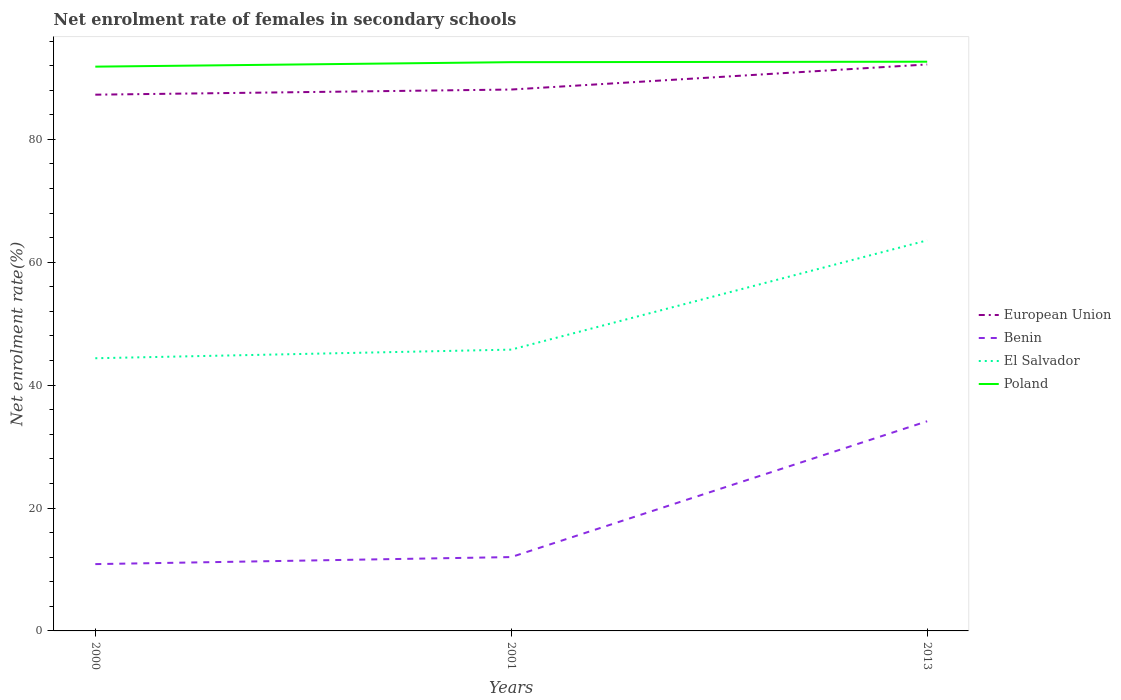Across all years, what is the maximum net enrolment rate of females in secondary schools in Benin?
Your response must be concise. 10.87. What is the total net enrolment rate of females in secondary schools in Poland in the graph?
Offer a terse response. -0.08. What is the difference between the highest and the second highest net enrolment rate of females in secondary schools in Benin?
Make the answer very short. 23.25. What is the difference between the highest and the lowest net enrolment rate of females in secondary schools in Poland?
Your response must be concise. 2. Does the graph contain any zero values?
Give a very brief answer. No. How are the legend labels stacked?
Keep it short and to the point. Vertical. What is the title of the graph?
Provide a succinct answer. Net enrolment rate of females in secondary schools. What is the label or title of the Y-axis?
Your answer should be very brief. Net enrolment rate(%). What is the Net enrolment rate(%) in European Union in 2000?
Provide a short and direct response. 87.27. What is the Net enrolment rate(%) in Benin in 2000?
Keep it short and to the point. 10.87. What is the Net enrolment rate(%) in El Salvador in 2000?
Provide a succinct answer. 44.38. What is the Net enrolment rate(%) of Poland in 2000?
Offer a terse response. 91.83. What is the Net enrolment rate(%) of European Union in 2001?
Offer a terse response. 88.1. What is the Net enrolment rate(%) of Benin in 2001?
Ensure brevity in your answer.  12.02. What is the Net enrolment rate(%) in El Salvador in 2001?
Your answer should be very brief. 45.78. What is the Net enrolment rate(%) in Poland in 2001?
Offer a terse response. 92.56. What is the Net enrolment rate(%) in European Union in 2013?
Give a very brief answer. 92.19. What is the Net enrolment rate(%) in Benin in 2013?
Keep it short and to the point. 34.12. What is the Net enrolment rate(%) of El Salvador in 2013?
Keep it short and to the point. 63.56. What is the Net enrolment rate(%) in Poland in 2013?
Your response must be concise. 92.63. Across all years, what is the maximum Net enrolment rate(%) of European Union?
Your response must be concise. 92.19. Across all years, what is the maximum Net enrolment rate(%) of Benin?
Your answer should be very brief. 34.12. Across all years, what is the maximum Net enrolment rate(%) of El Salvador?
Offer a terse response. 63.56. Across all years, what is the maximum Net enrolment rate(%) in Poland?
Your answer should be compact. 92.63. Across all years, what is the minimum Net enrolment rate(%) in European Union?
Provide a short and direct response. 87.27. Across all years, what is the minimum Net enrolment rate(%) in Benin?
Offer a terse response. 10.87. Across all years, what is the minimum Net enrolment rate(%) in El Salvador?
Give a very brief answer. 44.38. Across all years, what is the minimum Net enrolment rate(%) of Poland?
Keep it short and to the point. 91.83. What is the total Net enrolment rate(%) in European Union in the graph?
Make the answer very short. 267.56. What is the total Net enrolment rate(%) in Benin in the graph?
Your answer should be compact. 57.01. What is the total Net enrolment rate(%) of El Salvador in the graph?
Make the answer very short. 153.72. What is the total Net enrolment rate(%) of Poland in the graph?
Provide a short and direct response. 277.02. What is the difference between the Net enrolment rate(%) of European Union in 2000 and that in 2001?
Your answer should be compact. -0.84. What is the difference between the Net enrolment rate(%) of Benin in 2000 and that in 2001?
Give a very brief answer. -1.15. What is the difference between the Net enrolment rate(%) in El Salvador in 2000 and that in 2001?
Your response must be concise. -1.4. What is the difference between the Net enrolment rate(%) in Poland in 2000 and that in 2001?
Your answer should be very brief. -0.73. What is the difference between the Net enrolment rate(%) of European Union in 2000 and that in 2013?
Give a very brief answer. -4.92. What is the difference between the Net enrolment rate(%) of Benin in 2000 and that in 2013?
Your answer should be very brief. -23.25. What is the difference between the Net enrolment rate(%) in El Salvador in 2000 and that in 2013?
Your response must be concise. -19.19. What is the difference between the Net enrolment rate(%) in Poland in 2000 and that in 2013?
Make the answer very short. -0.81. What is the difference between the Net enrolment rate(%) of European Union in 2001 and that in 2013?
Ensure brevity in your answer.  -4.08. What is the difference between the Net enrolment rate(%) of Benin in 2001 and that in 2013?
Ensure brevity in your answer.  -22.1. What is the difference between the Net enrolment rate(%) in El Salvador in 2001 and that in 2013?
Your answer should be very brief. -17.78. What is the difference between the Net enrolment rate(%) of Poland in 2001 and that in 2013?
Ensure brevity in your answer.  -0.08. What is the difference between the Net enrolment rate(%) of European Union in 2000 and the Net enrolment rate(%) of Benin in 2001?
Provide a succinct answer. 75.25. What is the difference between the Net enrolment rate(%) of European Union in 2000 and the Net enrolment rate(%) of El Salvador in 2001?
Offer a terse response. 41.49. What is the difference between the Net enrolment rate(%) in European Union in 2000 and the Net enrolment rate(%) in Poland in 2001?
Your response must be concise. -5.29. What is the difference between the Net enrolment rate(%) of Benin in 2000 and the Net enrolment rate(%) of El Salvador in 2001?
Keep it short and to the point. -34.91. What is the difference between the Net enrolment rate(%) of Benin in 2000 and the Net enrolment rate(%) of Poland in 2001?
Ensure brevity in your answer.  -81.69. What is the difference between the Net enrolment rate(%) of El Salvador in 2000 and the Net enrolment rate(%) of Poland in 2001?
Offer a terse response. -48.18. What is the difference between the Net enrolment rate(%) of European Union in 2000 and the Net enrolment rate(%) of Benin in 2013?
Your answer should be compact. 53.15. What is the difference between the Net enrolment rate(%) of European Union in 2000 and the Net enrolment rate(%) of El Salvador in 2013?
Keep it short and to the point. 23.71. What is the difference between the Net enrolment rate(%) of European Union in 2000 and the Net enrolment rate(%) of Poland in 2013?
Your answer should be very brief. -5.37. What is the difference between the Net enrolment rate(%) in Benin in 2000 and the Net enrolment rate(%) in El Salvador in 2013?
Provide a short and direct response. -52.69. What is the difference between the Net enrolment rate(%) in Benin in 2000 and the Net enrolment rate(%) in Poland in 2013?
Keep it short and to the point. -81.76. What is the difference between the Net enrolment rate(%) of El Salvador in 2000 and the Net enrolment rate(%) of Poland in 2013?
Keep it short and to the point. -48.26. What is the difference between the Net enrolment rate(%) of European Union in 2001 and the Net enrolment rate(%) of Benin in 2013?
Give a very brief answer. 53.98. What is the difference between the Net enrolment rate(%) in European Union in 2001 and the Net enrolment rate(%) in El Salvador in 2013?
Ensure brevity in your answer.  24.54. What is the difference between the Net enrolment rate(%) of European Union in 2001 and the Net enrolment rate(%) of Poland in 2013?
Your answer should be very brief. -4.53. What is the difference between the Net enrolment rate(%) of Benin in 2001 and the Net enrolment rate(%) of El Salvador in 2013?
Your response must be concise. -51.54. What is the difference between the Net enrolment rate(%) of Benin in 2001 and the Net enrolment rate(%) of Poland in 2013?
Provide a succinct answer. -80.62. What is the difference between the Net enrolment rate(%) of El Salvador in 2001 and the Net enrolment rate(%) of Poland in 2013?
Ensure brevity in your answer.  -46.86. What is the average Net enrolment rate(%) in European Union per year?
Keep it short and to the point. 89.19. What is the average Net enrolment rate(%) of Benin per year?
Ensure brevity in your answer.  19. What is the average Net enrolment rate(%) in El Salvador per year?
Give a very brief answer. 51.24. What is the average Net enrolment rate(%) in Poland per year?
Make the answer very short. 92.34. In the year 2000, what is the difference between the Net enrolment rate(%) of European Union and Net enrolment rate(%) of Benin?
Ensure brevity in your answer.  76.4. In the year 2000, what is the difference between the Net enrolment rate(%) of European Union and Net enrolment rate(%) of El Salvador?
Your answer should be compact. 42.89. In the year 2000, what is the difference between the Net enrolment rate(%) of European Union and Net enrolment rate(%) of Poland?
Offer a terse response. -4.56. In the year 2000, what is the difference between the Net enrolment rate(%) of Benin and Net enrolment rate(%) of El Salvador?
Offer a very short reply. -33.5. In the year 2000, what is the difference between the Net enrolment rate(%) in Benin and Net enrolment rate(%) in Poland?
Provide a succinct answer. -80.96. In the year 2000, what is the difference between the Net enrolment rate(%) of El Salvador and Net enrolment rate(%) of Poland?
Your answer should be compact. -47.45. In the year 2001, what is the difference between the Net enrolment rate(%) of European Union and Net enrolment rate(%) of Benin?
Give a very brief answer. 76.08. In the year 2001, what is the difference between the Net enrolment rate(%) of European Union and Net enrolment rate(%) of El Salvador?
Keep it short and to the point. 42.32. In the year 2001, what is the difference between the Net enrolment rate(%) in European Union and Net enrolment rate(%) in Poland?
Your answer should be compact. -4.45. In the year 2001, what is the difference between the Net enrolment rate(%) of Benin and Net enrolment rate(%) of El Salvador?
Give a very brief answer. -33.76. In the year 2001, what is the difference between the Net enrolment rate(%) in Benin and Net enrolment rate(%) in Poland?
Your response must be concise. -80.54. In the year 2001, what is the difference between the Net enrolment rate(%) of El Salvador and Net enrolment rate(%) of Poland?
Your response must be concise. -46.78. In the year 2013, what is the difference between the Net enrolment rate(%) of European Union and Net enrolment rate(%) of Benin?
Your answer should be very brief. 58.07. In the year 2013, what is the difference between the Net enrolment rate(%) in European Union and Net enrolment rate(%) in El Salvador?
Give a very brief answer. 28.62. In the year 2013, what is the difference between the Net enrolment rate(%) of European Union and Net enrolment rate(%) of Poland?
Provide a succinct answer. -0.45. In the year 2013, what is the difference between the Net enrolment rate(%) in Benin and Net enrolment rate(%) in El Salvador?
Offer a terse response. -29.44. In the year 2013, what is the difference between the Net enrolment rate(%) in Benin and Net enrolment rate(%) in Poland?
Ensure brevity in your answer.  -58.51. In the year 2013, what is the difference between the Net enrolment rate(%) of El Salvador and Net enrolment rate(%) of Poland?
Give a very brief answer. -29.07. What is the ratio of the Net enrolment rate(%) of European Union in 2000 to that in 2001?
Offer a very short reply. 0.99. What is the ratio of the Net enrolment rate(%) of Benin in 2000 to that in 2001?
Provide a succinct answer. 0.9. What is the ratio of the Net enrolment rate(%) of El Salvador in 2000 to that in 2001?
Provide a succinct answer. 0.97. What is the ratio of the Net enrolment rate(%) in Poland in 2000 to that in 2001?
Ensure brevity in your answer.  0.99. What is the ratio of the Net enrolment rate(%) of European Union in 2000 to that in 2013?
Provide a short and direct response. 0.95. What is the ratio of the Net enrolment rate(%) of Benin in 2000 to that in 2013?
Offer a very short reply. 0.32. What is the ratio of the Net enrolment rate(%) of El Salvador in 2000 to that in 2013?
Your answer should be compact. 0.7. What is the ratio of the Net enrolment rate(%) in European Union in 2001 to that in 2013?
Your response must be concise. 0.96. What is the ratio of the Net enrolment rate(%) of Benin in 2001 to that in 2013?
Provide a short and direct response. 0.35. What is the ratio of the Net enrolment rate(%) of El Salvador in 2001 to that in 2013?
Provide a short and direct response. 0.72. What is the difference between the highest and the second highest Net enrolment rate(%) in European Union?
Offer a very short reply. 4.08. What is the difference between the highest and the second highest Net enrolment rate(%) of Benin?
Make the answer very short. 22.1. What is the difference between the highest and the second highest Net enrolment rate(%) in El Salvador?
Ensure brevity in your answer.  17.78. What is the difference between the highest and the second highest Net enrolment rate(%) of Poland?
Provide a succinct answer. 0.08. What is the difference between the highest and the lowest Net enrolment rate(%) in European Union?
Your answer should be compact. 4.92. What is the difference between the highest and the lowest Net enrolment rate(%) in Benin?
Provide a short and direct response. 23.25. What is the difference between the highest and the lowest Net enrolment rate(%) of El Salvador?
Provide a short and direct response. 19.19. What is the difference between the highest and the lowest Net enrolment rate(%) of Poland?
Give a very brief answer. 0.81. 